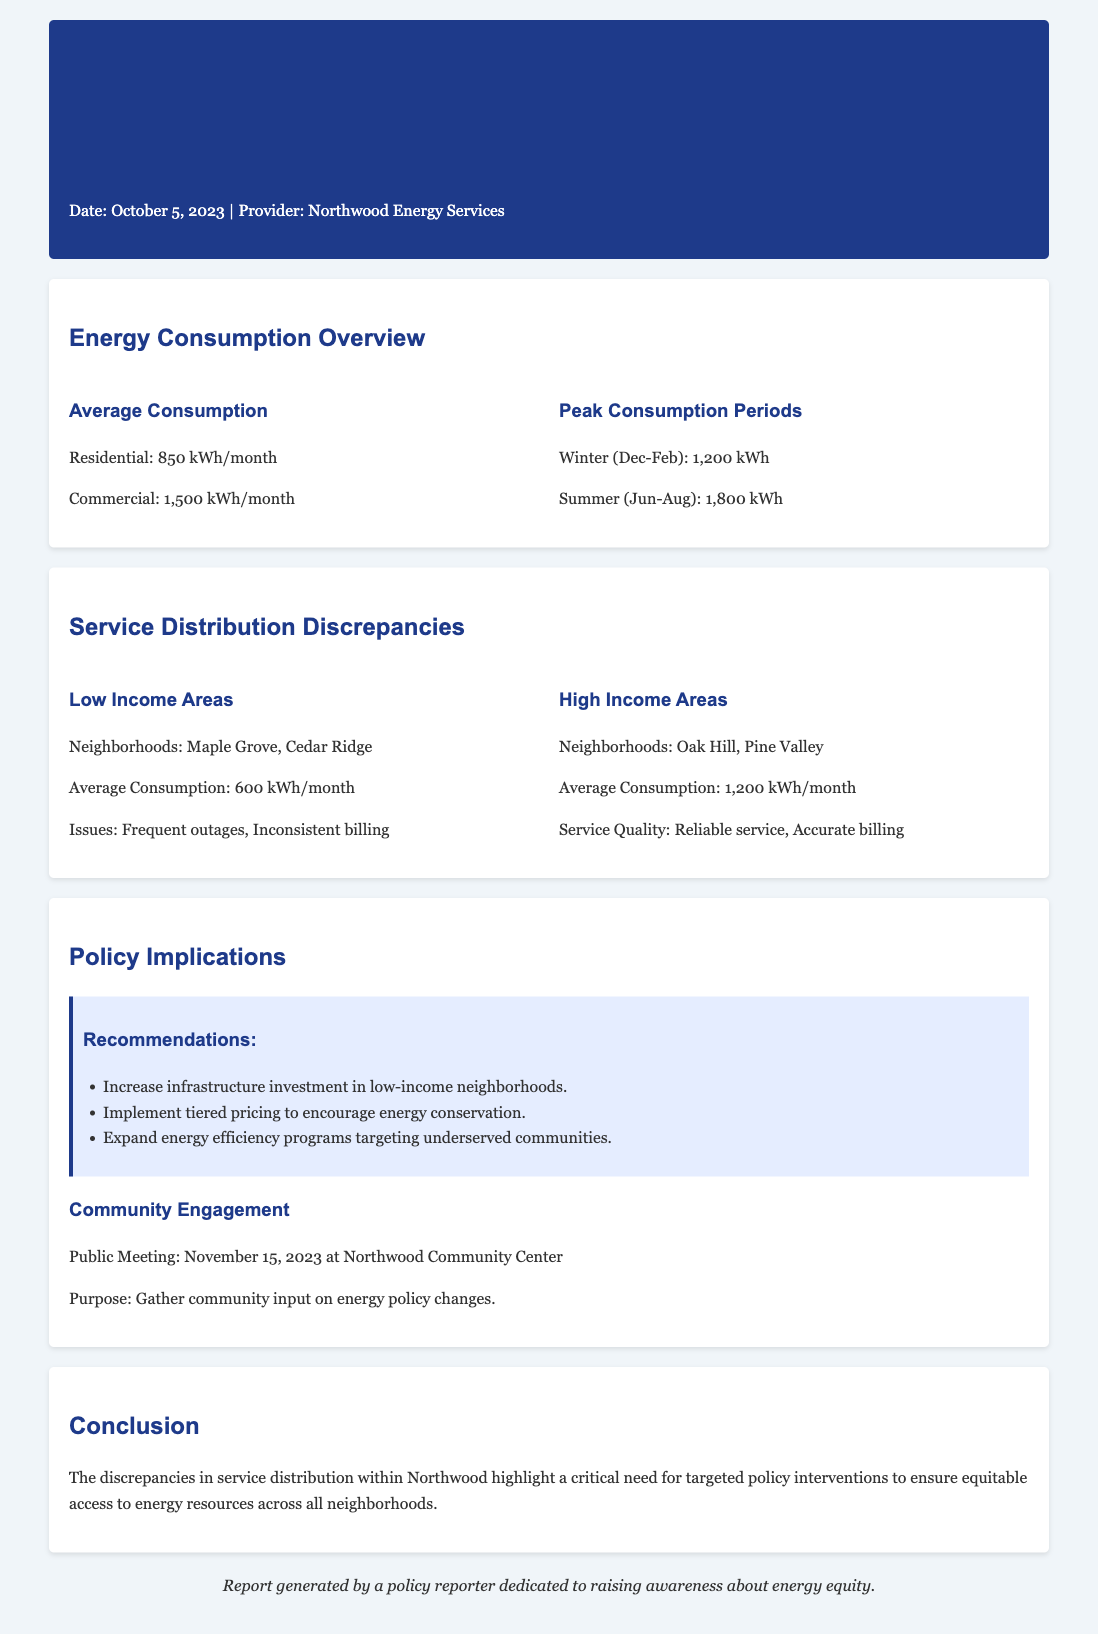What is the average residential consumption? The average residential consumption is stated in the document as 850 kWh/month.
Answer: 850 kWh/month What are the neighborhoods with low-income areas? The document lists "Maple Grove" and "Cedar Ridge" as neighborhoods in low-income areas.
Answer: Maple Grove, Cedar Ridge What is the peak consumption period for winter? The peak consumption for winter is specified in the document as 1,200 kWh.
Answer: 1,200 kWh What recommendations are made for low-income neighborhoods? The document recommends increasing infrastructure investment in low-income neighborhoods as a policy intervention.
Answer: Increase infrastructure investment What is the average consumption for high-income areas? The average consumption for high-income areas is stated as 1,200 kWh/month.
Answer: 1,200 kWh/month What is the date of the public meeting? The document states that the public meeting is scheduled for November 15, 2023.
Answer: November 15, 2023 What are the issues faced by low-income neighborhoods? The issues faced by low-income neighborhoods include frequent outages and inconsistent billing as mentioned in the document.
Answer: Frequent outages, Inconsistent billing What is the purpose of the public meeting? The purpose of the public meeting is to gather community input on energy policy changes as outlined in the document.
Answer: Gather community input on energy policy changes What is the date of the utility statement? The date of the utility statement is mentioned as October 5, 2023.
Answer: October 5, 2023 